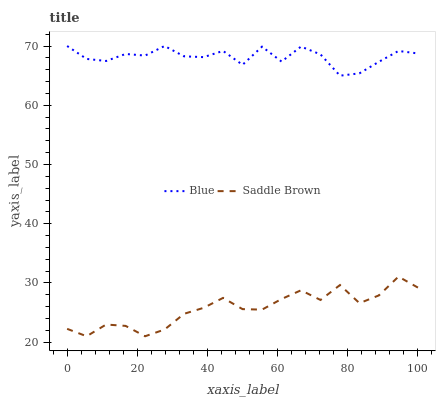Does Saddle Brown have the minimum area under the curve?
Answer yes or no. Yes. Does Blue have the maximum area under the curve?
Answer yes or no. Yes. Does Saddle Brown have the maximum area under the curve?
Answer yes or no. No. Is Saddle Brown the smoothest?
Answer yes or no. Yes. Is Blue the roughest?
Answer yes or no. Yes. Is Saddle Brown the roughest?
Answer yes or no. No. Does Saddle Brown have the lowest value?
Answer yes or no. Yes. Does Blue have the highest value?
Answer yes or no. Yes. Does Saddle Brown have the highest value?
Answer yes or no. No. Is Saddle Brown less than Blue?
Answer yes or no. Yes. Is Blue greater than Saddle Brown?
Answer yes or no. Yes. Does Saddle Brown intersect Blue?
Answer yes or no. No. 